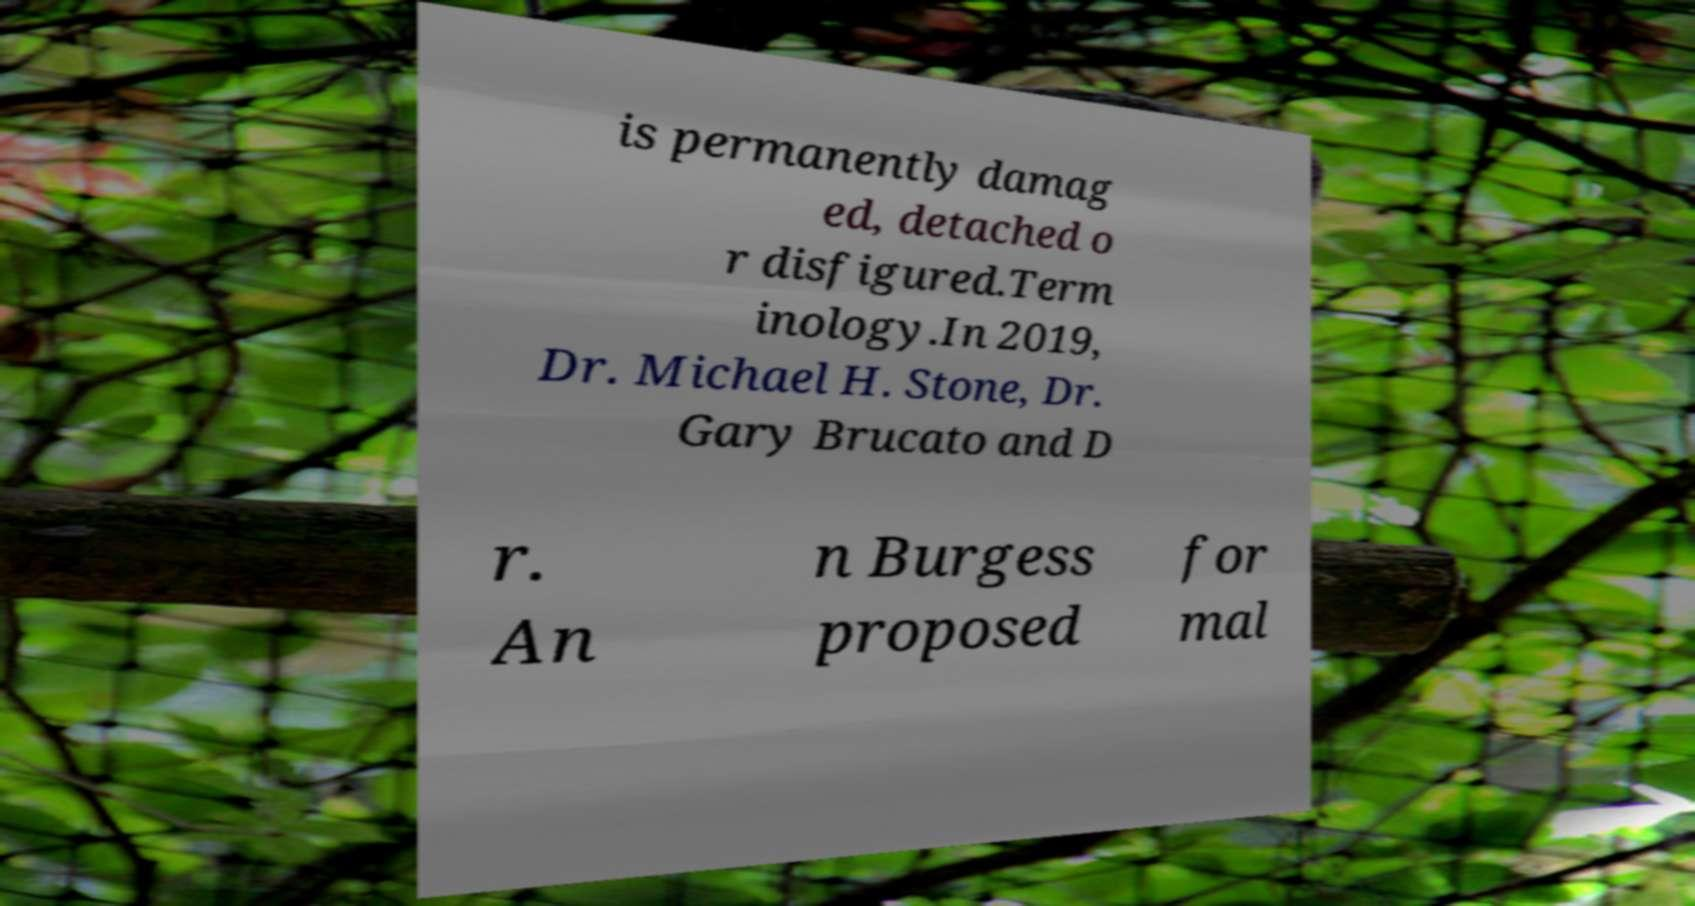For documentation purposes, I need the text within this image transcribed. Could you provide that? is permanently damag ed, detached o r disfigured.Term inology.In 2019, Dr. Michael H. Stone, Dr. Gary Brucato and D r. An n Burgess proposed for mal 